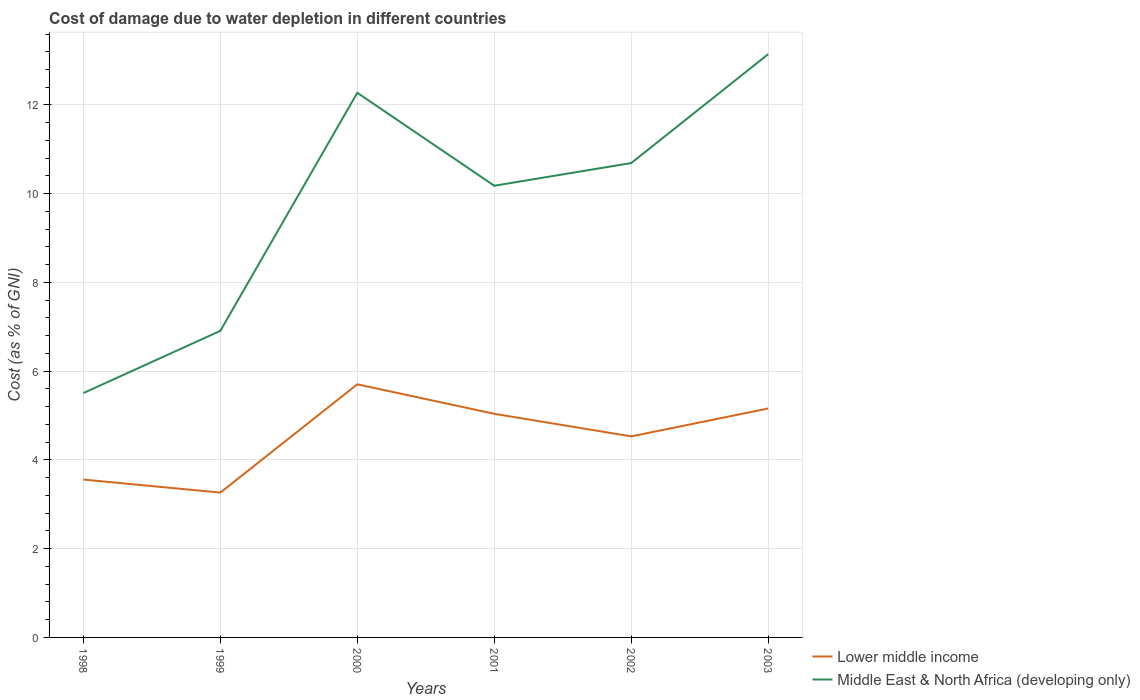How many different coloured lines are there?
Your answer should be very brief. 2. Does the line corresponding to Lower middle income intersect with the line corresponding to Middle East & North Africa (developing only)?
Provide a succinct answer. No. Across all years, what is the maximum cost of damage caused due to water depletion in Lower middle income?
Keep it short and to the point. 3.26. In which year was the cost of damage caused due to water depletion in Middle East & North Africa (developing only) maximum?
Offer a very short reply. 1998. What is the total cost of damage caused due to water depletion in Lower middle income in the graph?
Your response must be concise. 1.17. What is the difference between the highest and the second highest cost of damage caused due to water depletion in Middle East & North Africa (developing only)?
Provide a short and direct response. 7.64. How many years are there in the graph?
Your answer should be compact. 6. How many legend labels are there?
Your answer should be very brief. 2. What is the title of the graph?
Give a very brief answer. Cost of damage due to water depletion in different countries. Does "Isle of Man" appear as one of the legend labels in the graph?
Your answer should be compact. No. What is the label or title of the Y-axis?
Offer a very short reply. Cost (as % of GNI). What is the Cost (as % of GNI) of Lower middle income in 1998?
Make the answer very short. 3.56. What is the Cost (as % of GNI) in Middle East & North Africa (developing only) in 1998?
Offer a very short reply. 5.51. What is the Cost (as % of GNI) in Lower middle income in 1999?
Ensure brevity in your answer.  3.26. What is the Cost (as % of GNI) in Middle East & North Africa (developing only) in 1999?
Your response must be concise. 6.91. What is the Cost (as % of GNI) of Lower middle income in 2000?
Your answer should be compact. 5.7. What is the Cost (as % of GNI) in Middle East & North Africa (developing only) in 2000?
Your answer should be very brief. 12.28. What is the Cost (as % of GNI) in Lower middle income in 2001?
Make the answer very short. 5.04. What is the Cost (as % of GNI) in Middle East & North Africa (developing only) in 2001?
Offer a terse response. 10.18. What is the Cost (as % of GNI) of Lower middle income in 2002?
Give a very brief answer. 4.53. What is the Cost (as % of GNI) in Middle East & North Africa (developing only) in 2002?
Your answer should be compact. 10.69. What is the Cost (as % of GNI) in Lower middle income in 2003?
Provide a succinct answer. 5.16. What is the Cost (as % of GNI) in Middle East & North Africa (developing only) in 2003?
Ensure brevity in your answer.  13.15. Across all years, what is the maximum Cost (as % of GNI) in Lower middle income?
Ensure brevity in your answer.  5.7. Across all years, what is the maximum Cost (as % of GNI) of Middle East & North Africa (developing only)?
Your response must be concise. 13.15. Across all years, what is the minimum Cost (as % of GNI) of Lower middle income?
Keep it short and to the point. 3.26. Across all years, what is the minimum Cost (as % of GNI) in Middle East & North Africa (developing only)?
Ensure brevity in your answer.  5.51. What is the total Cost (as % of GNI) in Lower middle income in the graph?
Ensure brevity in your answer.  27.26. What is the total Cost (as % of GNI) of Middle East & North Africa (developing only) in the graph?
Provide a succinct answer. 58.71. What is the difference between the Cost (as % of GNI) in Lower middle income in 1998 and that in 1999?
Your response must be concise. 0.29. What is the difference between the Cost (as % of GNI) in Middle East & North Africa (developing only) in 1998 and that in 1999?
Ensure brevity in your answer.  -1.4. What is the difference between the Cost (as % of GNI) in Lower middle income in 1998 and that in 2000?
Provide a short and direct response. -2.15. What is the difference between the Cost (as % of GNI) in Middle East & North Africa (developing only) in 1998 and that in 2000?
Offer a terse response. -6.77. What is the difference between the Cost (as % of GNI) of Lower middle income in 1998 and that in 2001?
Give a very brief answer. -1.48. What is the difference between the Cost (as % of GNI) in Middle East & North Africa (developing only) in 1998 and that in 2001?
Offer a terse response. -4.67. What is the difference between the Cost (as % of GNI) in Lower middle income in 1998 and that in 2002?
Provide a short and direct response. -0.97. What is the difference between the Cost (as % of GNI) of Middle East & North Africa (developing only) in 1998 and that in 2002?
Provide a succinct answer. -5.18. What is the difference between the Cost (as % of GNI) in Lower middle income in 1998 and that in 2003?
Keep it short and to the point. -1.6. What is the difference between the Cost (as % of GNI) in Middle East & North Africa (developing only) in 1998 and that in 2003?
Make the answer very short. -7.64. What is the difference between the Cost (as % of GNI) of Lower middle income in 1999 and that in 2000?
Offer a terse response. -2.44. What is the difference between the Cost (as % of GNI) in Middle East & North Africa (developing only) in 1999 and that in 2000?
Your response must be concise. -5.37. What is the difference between the Cost (as % of GNI) in Lower middle income in 1999 and that in 2001?
Provide a short and direct response. -1.78. What is the difference between the Cost (as % of GNI) of Middle East & North Africa (developing only) in 1999 and that in 2001?
Provide a short and direct response. -3.27. What is the difference between the Cost (as % of GNI) in Lower middle income in 1999 and that in 2002?
Your answer should be compact. -1.27. What is the difference between the Cost (as % of GNI) of Middle East & North Africa (developing only) in 1999 and that in 2002?
Your answer should be compact. -3.78. What is the difference between the Cost (as % of GNI) in Lower middle income in 1999 and that in 2003?
Make the answer very short. -1.9. What is the difference between the Cost (as % of GNI) of Middle East & North Africa (developing only) in 1999 and that in 2003?
Offer a very short reply. -6.24. What is the difference between the Cost (as % of GNI) of Lower middle income in 2000 and that in 2001?
Your answer should be compact. 0.66. What is the difference between the Cost (as % of GNI) in Middle East & North Africa (developing only) in 2000 and that in 2001?
Your response must be concise. 2.1. What is the difference between the Cost (as % of GNI) in Lower middle income in 2000 and that in 2002?
Provide a short and direct response. 1.17. What is the difference between the Cost (as % of GNI) of Middle East & North Africa (developing only) in 2000 and that in 2002?
Give a very brief answer. 1.58. What is the difference between the Cost (as % of GNI) in Lower middle income in 2000 and that in 2003?
Make the answer very short. 0.55. What is the difference between the Cost (as % of GNI) in Middle East & North Africa (developing only) in 2000 and that in 2003?
Your answer should be very brief. -0.87. What is the difference between the Cost (as % of GNI) in Lower middle income in 2001 and that in 2002?
Offer a very short reply. 0.51. What is the difference between the Cost (as % of GNI) in Middle East & North Africa (developing only) in 2001 and that in 2002?
Your answer should be very brief. -0.51. What is the difference between the Cost (as % of GNI) of Lower middle income in 2001 and that in 2003?
Make the answer very short. -0.12. What is the difference between the Cost (as % of GNI) of Middle East & North Africa (developing only) in 2001 and that in 2003?
Your response must be concise. -2.97. What is the difference between the Cost (as % of GNI) of Lower middle income in 2002 and that in 2003?
Offer a terse response. -0.63. What is the difference between the Cost (as % of GNI) of Middle East & North Africa (developing only) in 2002 and that in 2003?
Make the answer very short. -2.45. What is the difference between the Cost (as % of GNI) in Lower middle income in 1998 and the Cost (as % of GNI) in Middle East & North Africa (developing only) in 1999?
Provide a short and direct response. -3.35. What is the difference between the Cost (as % of GNI) of Lower middle income in 1998 and the Cost (as % of GNI) of Middle East & North Africa (developing only) in 2000?
Ensure brevity in your answer.  -8.72. What is the difference between the Cost (as % of GNI) of Lower middle income in 1998 and the Cost (as % of GNI) of Middle East & North Africa (developing only) in 2001?
Provide a short and direct response. -6.62. What is the difference between the Cost (as % of GNI) in Lower middle income in 1998 and the Cost (as % of GNI) in Middle East & North Africa (developing only) in 2002?
Provide a short and direct response. -7.13. What is the difference between the Cost (as % of GNI) in Lower middle income in 1998 and the Cost (as % of GNI) in Middle East & North Africa (developing only) in 2003?
Your answer should be very brief. -9.59. What is the difference between the Cost (as % of GNI) of Lower middle income in 1999 and the Cost (as % of GNI) of Middle East & North Africa (developing only) in 2000?
Provide a succinct answer. -9.01. What is the difference between the Cost (as % of GNI) of Lower middle income in 1999 and the Cost (as % of GNI) of Middle East & North Africa (developing only) in 2001?
Give a very brief answer. -6.92. What is the difference between the Cost (as % of GNI) of Lower middle income in 1999 and the Cost (as % of GNI) of Middle East & North Africa (developing only) in 2002?
Give a very brief answer. -7.43. What is the difference between the Cost (as % of GNI) of Lower middle income in 1999 and the Cost (as % of GNI) of Middle East & North Africa (developing only) in 2003?
Your answer should be very brief. -9.88. What is the difference between the Cost (as % of GNI) in Lower middle income in 2000 and the Cost (as % of GNI) in Middle East & North Africa (developing only) in 2001?
Offer a terse response. -4.48. What is the difference between the Cost (as % of GNI) of Lower middle income in 2000 and the Cost (as % of GNI) of Middle East & North Africa (developing only) in 2002?
Make the answer very short. -4.99. What is the difference between the Cost (as % of GNI) of Lower middle income in 2000 and the Cost (as % of GNI) of Middle East & North Africa (developing only) in 2003?
Give a very brief answer. -7.44. What is the difference between the Cost (as % of GNI) of Lower middle income in 2001 and the Cost (as % of GNI) of Middle East & North Africa (developing only) in 2002?
Offer a terse response. -5.65. What is the difference between the Cost (as % of GNI) in Lower middle income in 2001 and the Cost (as % of GNI) in Middle East & North Africa (developing only) in 2003?
Provide a succinct answer. -8.11. What is the difference between the Cost (as % of GNI) of Lower middle income in 2002 and the Cost (as % of GNI) of Middle East & North Africa (developing only) in 2003?
Give a very brief answer. -8.61. What is the average Cost (as % of GNI) of Lower middle income per year?
Your response must be concise. 4.54. What is the average Cost (as % of GNI) of Middle East & North Africa (developing only) per year?
Provide a short and direct response. 9.79. In the year 1998, what is the difference between the Cost (as % of GNI) of Lower middle income and Cost (as % of GNI) of Middle East & North Africa (developing only)?
Keep it short and to the point. -1.95. In the year 1999, what is the difference between the Cost (as % of GNI) in Lower middle income and Cost (as % of GNI) in Middle East & North Africa (developing only)?
Your answer should be compact. -3.65. In the year 2000, what is the difference between the Cost (as % of GNI) in Lower middle income and Cost (as % of GNI) in Middle East & North Africa (developing only)?
Ensure brevity in your answer.  -6.57. In the year 2001, what is the difference between the Cost (as % of GNI) of Lower middle income and Cost (as % of GNI) of Middle East & North Africa (developing only)?
Offer a very short reply. -5.14. In the year 2002, what is the difference between the Cost (as % of GNI) of Lower middle income and Cost (as % of GNI) of Middle East & North Africa (developing only)?
Offer a terse response. -6.16. In the year 2003, what is the difference between the Cost (as % of GNI) of Lower middle income and Cost (as % of GNI) of Middle East & North Africa (developing only)?
Ensure brevity in your answer.  -7.99. What is the ratio of the Cost (as % of GNI) in Lower middle income in 1998 to that in 1999?
Offer a terse response. 1.09. What is the ratio of the Cost (as % of GNI) in Middle East & North Africa (developing only) in 1998 to that in 1999?
Keep it short and to the point. 0.8. What is the ratio of the Cost (as % of GNI) of Lower middle income in 1998 to that in 2000?
Your answer should be compact. 0.62. What is the ratio of the Cost (as % of GNI) of Middle East & North Africa (developing only) in 1998 to that in 2000?
Make the answer very short. 0.45. What is the ratio of the Cost (as % of GNI) in Lower middle income in 1998 to that in 2001?
Make the answer very short. 0.71. What is the ratio of the Cost (as % of GNI) of Middle East & North Africa (developing only) in 1998 to that in 2001?
Offer a terse response. 0.54. What is the ratio of the Cost (as % of GNI) of Lower middle income in 1998 to that in 2002?
Provide a short and direct response. 0.79. What is the ratio of the Cost (as % of GNI) of Middle East & North Africa (developing only) in 1998 to that in 2002?
Ensure brevity in your answer.  0.52. What is the ratio of the Cost (as % of GNI) in Lower middle income in 1998 to that in 2003?
Your response must be concise. 0.69. What is the ratio of the Cost (as % of GNI) in Middle East & North Africa (developing only) in 1998 to that in 2003?
Your response must be concise. 0.42. What is the ratio of the Cost (as % of GNI) in Lower middle income in 1999 to that in 2000?
Ensure brevity in your answer.  0.57. What is the ratio of the Cost (as % of GNI) in Middle East & North Africa (developing only) in 1999 to that in 2000?
Your response must be concise. 0.56. What is the ratio of the Cost (as % of GNI) of Lower middle income in 1999 to that in 2001?
Offer a very short reply. 0.65. What is the ratio of the Cost (as % of GNI) in Middle East & North Africa (developing only) in 1999 to that in 2001?
Offer a terse response. 0.68. What is the ratio of the Cost (as % of GNI) of Lower middle income in 1999 to that in 2002?
Ensure brevity in your answer.  0.72. What is the ratio of the Cost (as % of GNI) in Middle East & North Africa (developing only) in 1999 to that in 2002?
Your response must be concise. 0.65. What is the ratio of the Cost (as % of GNI) of Lower middle income in 1999 to that in 2003?
Provide a succinct answer. 0.63. What is the ratio of the Cost (as % of GNI) of Middle East & North Africa (developing only) in 1999 to that in 2003?
Offer a terse response. 0.53. What is the ratio of the Cost (as % of GNI) of Lower middle income in 2000 to that in 2001?
Provide a short and direct response. 1.13. What is the ratio of the Cost (as % of GNI) of Middle East & North Africa (developing only) in 2000 to that in 2001?
Your response must be concise. 1.21. What is the ratio of the Cost (as % of GNI) in Lower middle income in 2000 to that in 2002?
Your response must be concise. 1.26. What is the ratio of the Cost (as % of GNI) in Middle East & North Africa (developing only) in 2000 to that in 2002?
Offer a very short reply. 1.15. What is the ratio of the Cost (as % of GNI) of Lower middle income in 2000 to that in 2003?
Provide a short and direct response. 1.11. What is the ratio of the Cost (as % of GNI) of Middle East & North Africa (developing only) in 2000 to that in 2003?
Your answer should be compact. 0.93. What is the ratio of the Cost (as % of GNI) of Lower middle income in 2001 to that in 2002?
Keep it short and to the point. 1.11. What is the ratio of the Cost (as % of GNI) of Middle East & North Africa (developing only) in 2001 to that in 2002?
Offer a terse response. 0.95. What is the ratio of the Cost (as % of GNI) of Lower middle income in 2001 to that in 2003?
Offer a terse response. 0.98. What is the ratio of the Cost (as % of GNI) of Middle East & North Africa (developing only) in 2001 to that in 2003?
Offer a terse response. 0.77. What is the ratio of the Cost (as % of GNI) in Lower middle income in 2002 to that in 2003?
Your answer should be compact. 0.88. What is the ratio of the Cost (as % of GNI) of Middle East & North Africa (developing only) in 2002 to that in 2003?
Ensure brevity in your answer.  0.81. What is the difference between the highest and the second highest Cost (as % of GNI) of Lower middle income?
Your response must be concise. 0.55. What is the difference between the highest and the second highest Cost (as % of GNI) of Middle East & North Africa (developing only)?
Your answer should be very brief. 0.87. What is the difference between the highest and the lowest Cost (as % of GNI) in Lower middle income?
Offer a terse response. 2.44. What is the difference between the highest and the lowest Cost (as % of GNI) of Middle East & North Africa (developing only)?
Offer a very short reply. 7.64. 